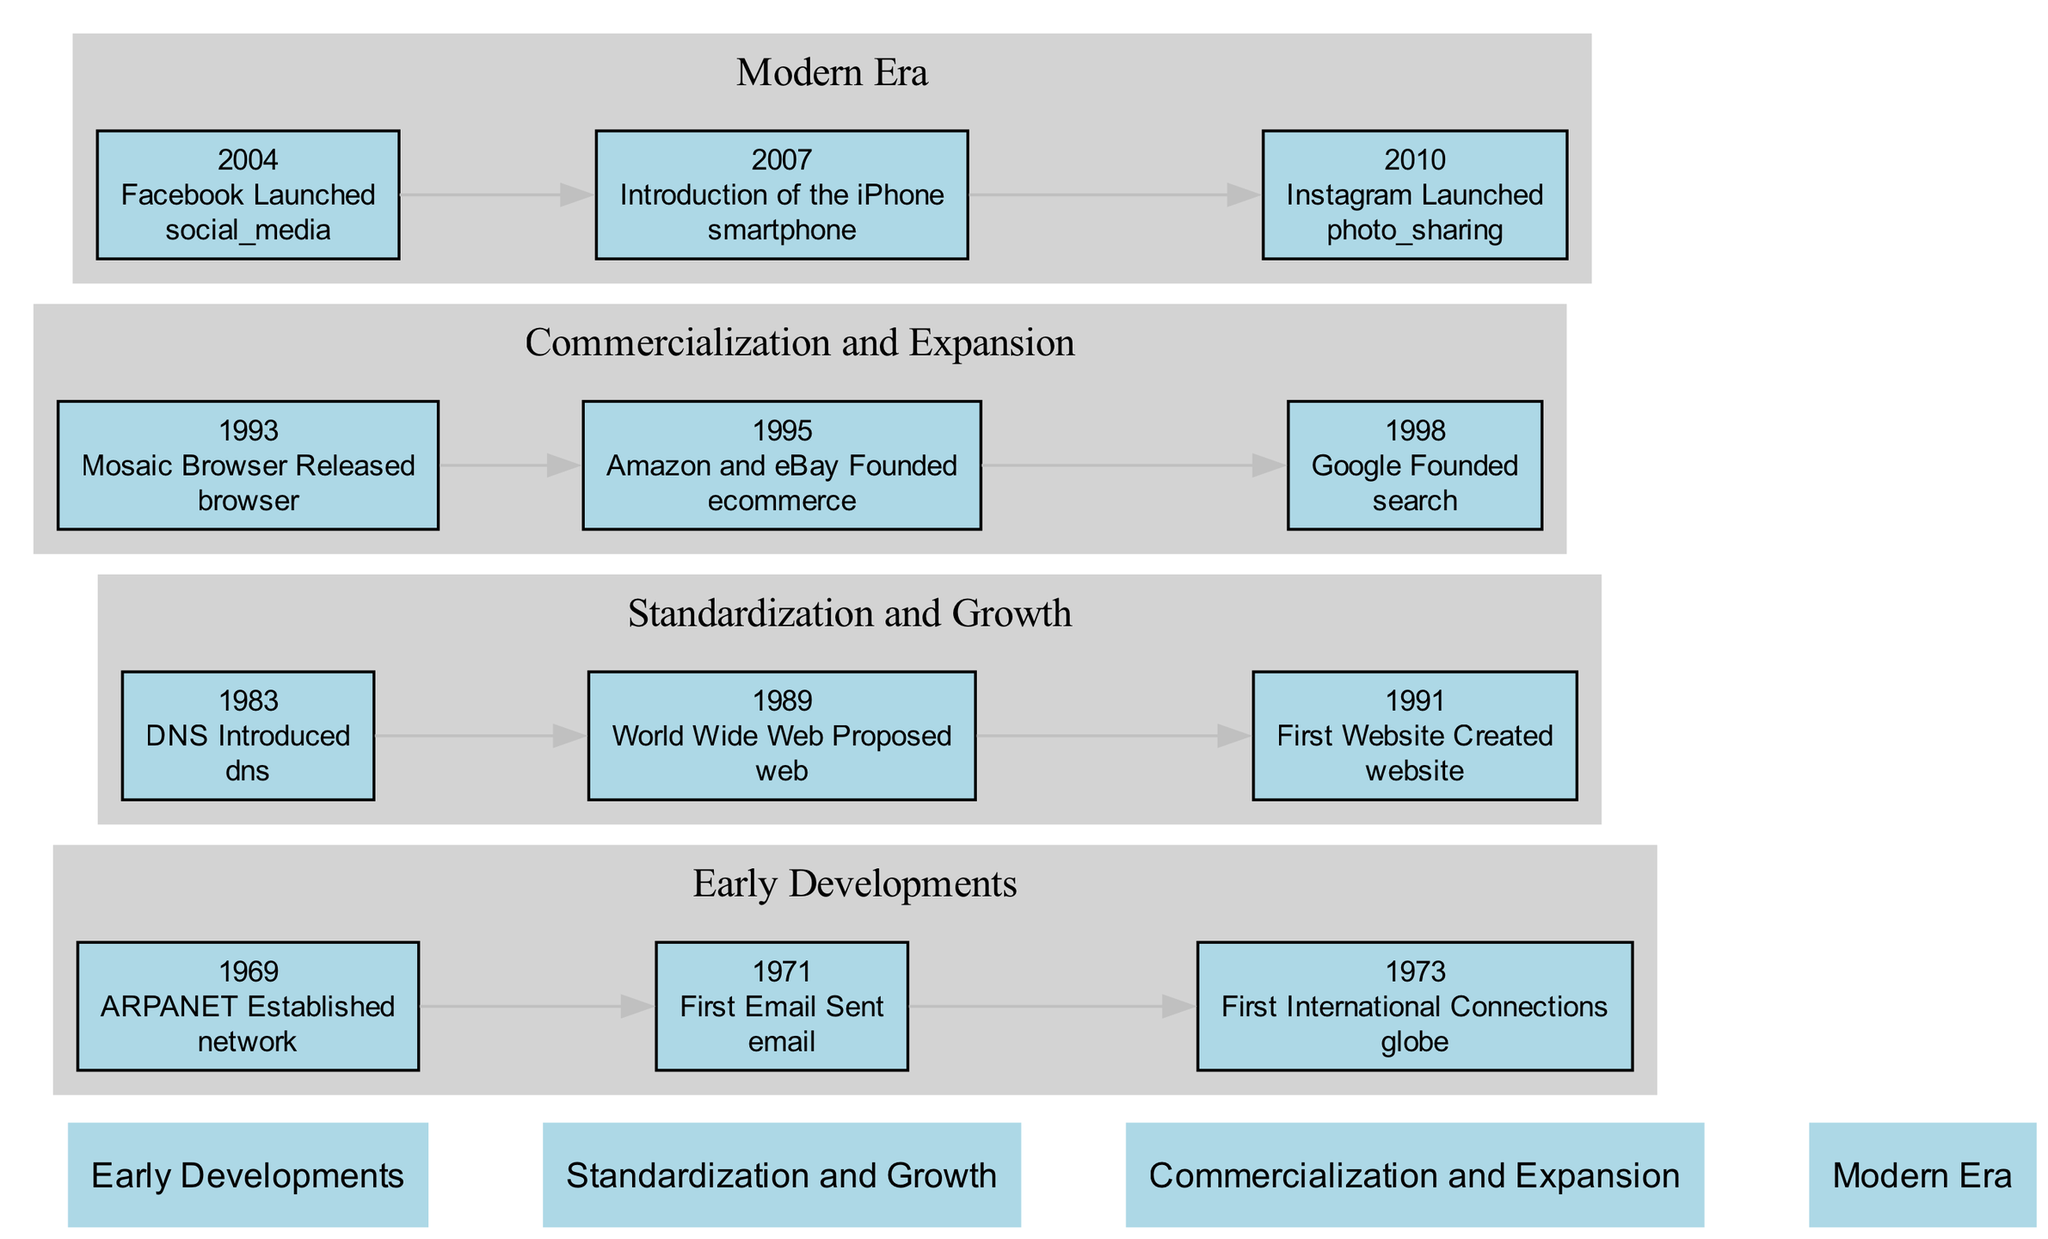What year was ARPANET established? The diagram indicates that ARPANET was established in the year 1969, as the corresponding node under the "Early Developments" layer displays this information.
Answer: 1969 What significant event happened in 1983? The diagram shows that in 1983, DNS was introduced, which is marked clearly in the "Standardization and Growth" layer.
Answer: DNS Introduced How many layers are there in the timeline? By counting the distinct layers listed in the diagram, we find that there are four layers: Early Developments, Standardization and Growth, Commercialization and Expansion, and Modern Era.
Answer: 4 What icon represents the first website created in 1991? The node under "Standardization and Growth" for the event "First Website Created" in 1991 uses the icon labeled 'website', denoting it visually.
Answer: website Which event follows the introduction of the iPhone? Within the "Modern Era" layer, the introduction of the iPhone in 2007 is followed by the event "Instagram Launched" in 2010, as shown in the same layer's node order.
Answer: Instagram Launched What is the relationship between the years 1995 and 1998 in the diagram? The diagram shows a direct connection from the event "Amazon and eBay Founded" in 1995 to the event "Google Founded" in 1998, indicating these events are sequential milestones in the "Commercialization and Expansion" layer.
Answer: Amazon and eBay Founded to Google Founded What does the icon in the "Early Developments" layer for the year 1971 represent? The icon associated with the event "First Email Sent" in 1971 in the "Early Developments" layer signifies 'email', indicating its relevance to communication technology progression.
Answer: email Which layer contains the largest span of years between its earliest and latest events? By inspecting the layers, "Commercialization and Expansion" has events spanning from 1993 to 1998, which is a 5-year span, the largest compared to the other layers.
Answer: Commercialization and Expansion In which layer is the event "Facebook Launched" located? The event "Facebook Launched" is located in the "Modern Era" layer, as explicitly labeled under this segment in the diagram.
Answer: Modern Era 